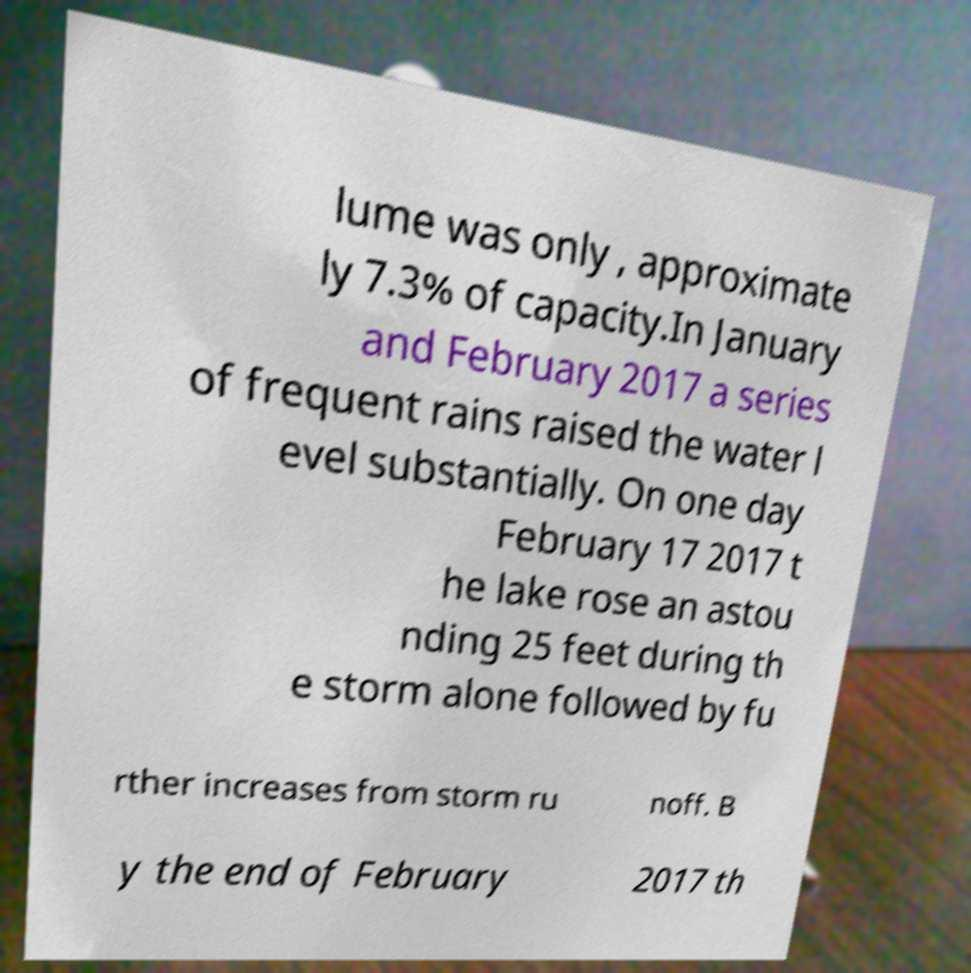Could you assist in decoding the text presented in this image and type it out clearly? lume was only , approximate ly 7.3% of capacity.In January and February 2017 a series of frequent rains raised the water l evel substantially. On one day February 17 2017 t he lake rose an astou nding 25 feet during th e storm alone followed by fu rther increases from storm ru noff. B y the end of February 2017 th 